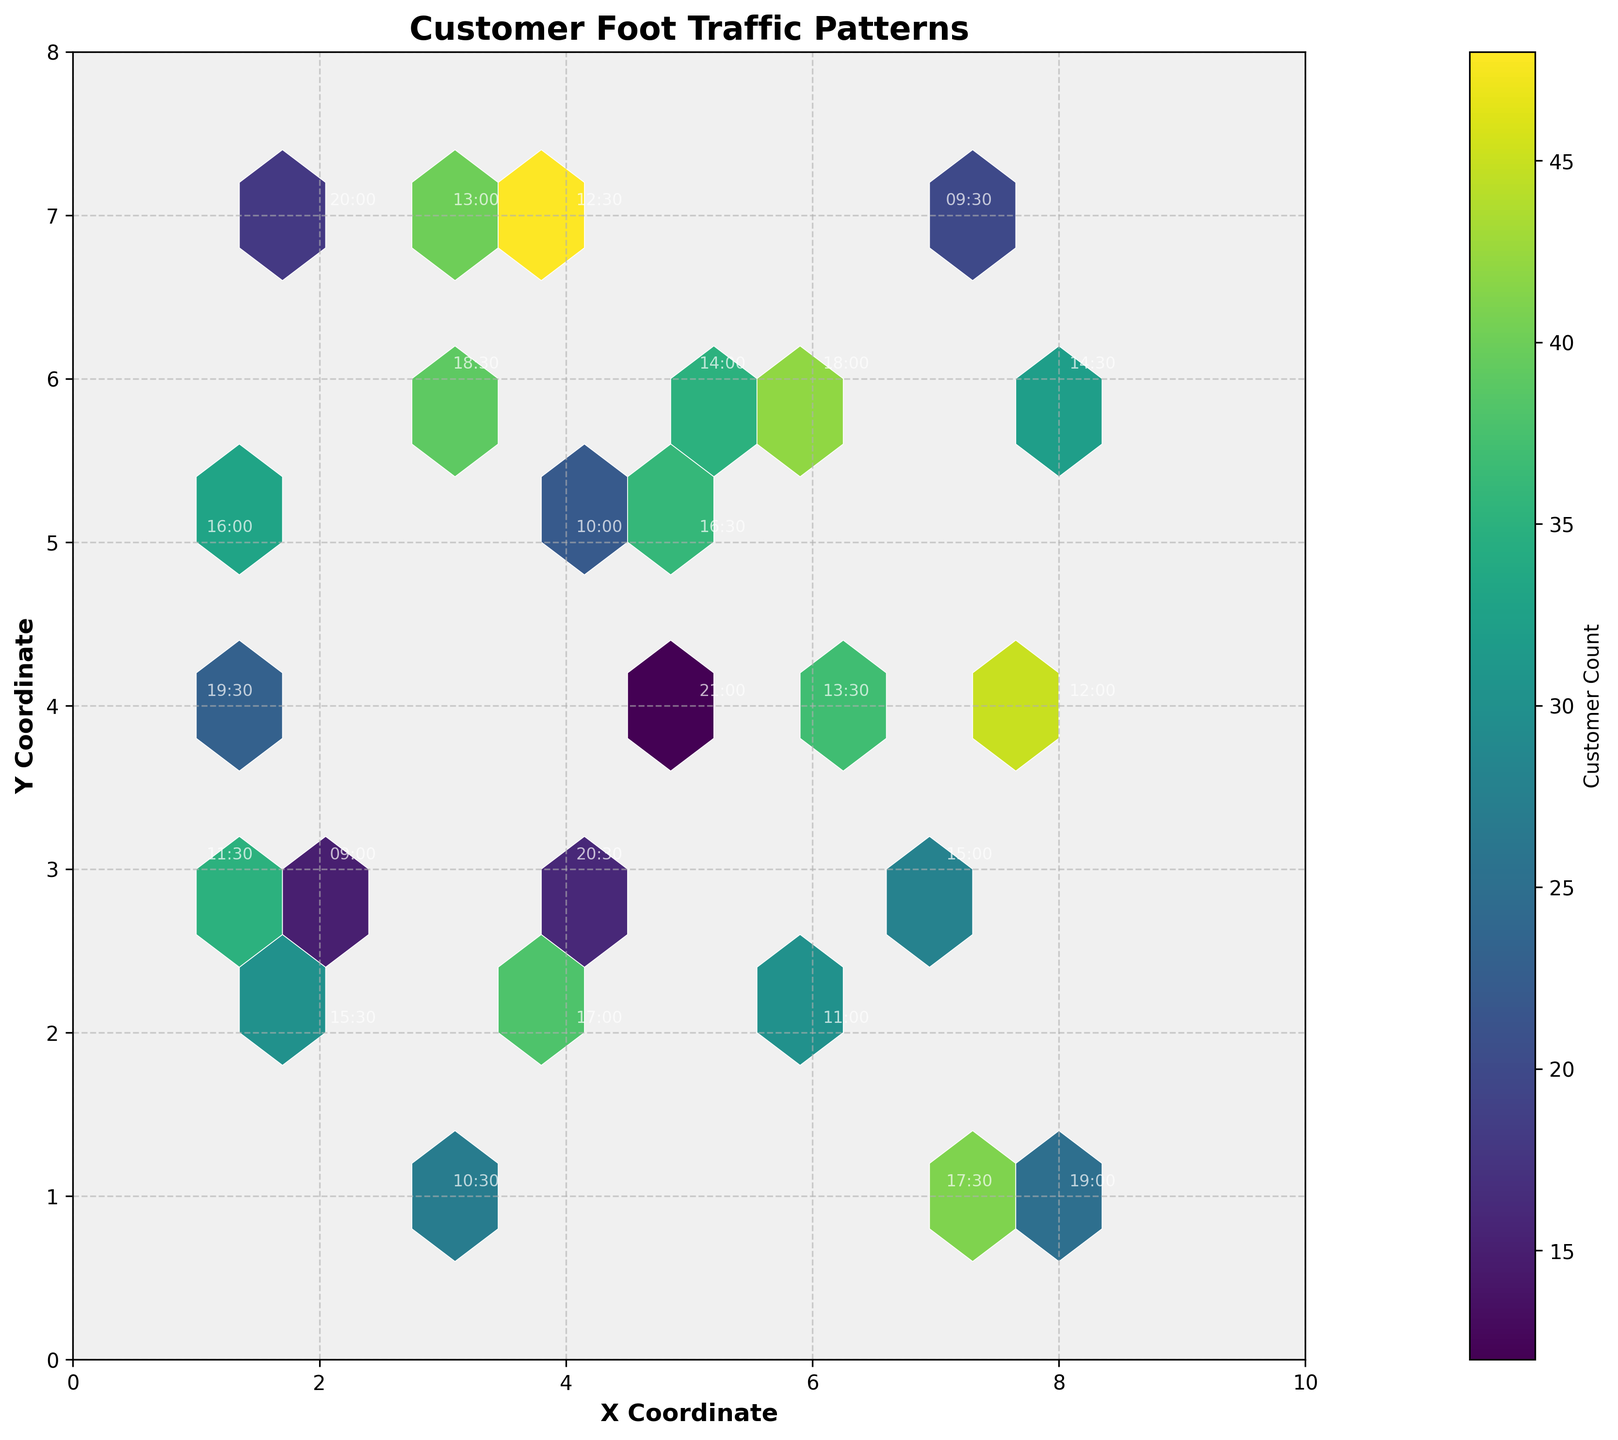What is the range of X coordinates plotted on the hexbin plot? The range of X coordinates can be determined by looking at the x-axis. The minimum value on the x-axis is 0, and the maximum value is 10.
Answer: 0 to 10 What is the title of the hexbin plot? The title of the hexbin plot is written at the top center of the plot. The text states "Customer Foot Traffic Patterns."
Answer: Customer Foot Traffic Patterns Which coordinate has the highest customer count? By looking at the color intensity on the plot, we identify the darkest hexagon which indicates the highest customer count. The hexagon at (4, 7) has the darkest color.
Answer: (4, 7) Which time of day corresponds to the highest customer count, and what is that count? The time annotated at the coordinate (4, 7) will indicate the highest count. The time is 12:30, and the count was 48.
Answer: 12:30, 48 How do customer counts generally change over the time of day? Annotated times spread across different coordinates show that larger customer counts occur between 11:00 and 18:30, as evidenced by the darker colors during these times.
Answer: Higher counts generally occur between 11:00 and 18:30 How many data points are annotated in the hexbin plot? Each annotated time corresponds to a data point. By counting them, we find there are 24 such points noted on the plot.
Answer: 24 What coordinate and time of day show the lowest customer count in the plot? The lightest colored hexagon signifies the lowest count. By examining the corresponding annotation, the coordinate is (5, 4) with the time of 21:00, and the count was 12.
Answer: (5, 4), 21:00 At which coordinates do customer counts tend to cluster the most? By observing the plot, clusters of darker hexagons reveal where counts are concentrated. Coordinates around (4, 7) and (6, 6) show heavy clustering due to their darker colors.
Answer: Around (4, 7) and (6, 6) Is there any time of day represented in a hexagon with customer count of at least 40? If so, what coordinates and times are they? By cross-referencing the hexagons with significant dark shades hinting at counts of 40 or above, and their corresponding annotations, we identify (3, 7) at 13:00, (4, 7) at 12:30, and (6, 6) at 18:00.
Answer: (3, 7) at 13:00; (4, 7) at 12:30; (6, 6) at 18:00 Between 10:00 and 16:30, which time has the peak customer count and what is that count? Focusing on only the times between 10:00 and 16:30, the count around 12:30 at (4, 7) peaks at 48.
Answer: 12:30, 48 